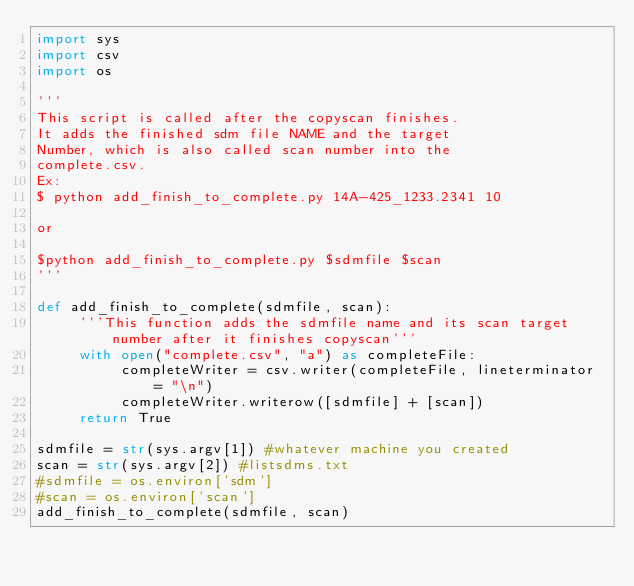<code> <loc_0><loc_0><loc_500><loc_500><_Python_>import sys
import csv
import os

'''
This script is called after the copyscan finishes.
It adds the finished sdm file NAME and the target
Number, which is also called scan number into the 
complete.csv.
Ex:
$ python add_finish_to_complete.py 14A-425_1233.2341 10

or

$python add_finish_to_complete.py $sdmfile $scan
'''

def add_finish_to_complete(sdmfile, scan):
     '''This function adds the sdmfile name and its scan target number after it finishes copyscan'''
     with open("complete.csv", "a") as completeFile:
          completeWriter = csv.writer(completeFile, lineterminator = "\n")
          completeWriter.writerow([sdmfile] + [scan])
     return True

sdmfile = str(sys.argv[1]) #whatever machine you created
scan = str(sys.argv[2]) #listsdms.txt
#sdmfile = os.environ['sdm']
#scan = os.environ['scan']
add_finish_to_complete(sdmfile, scan)
</code> 